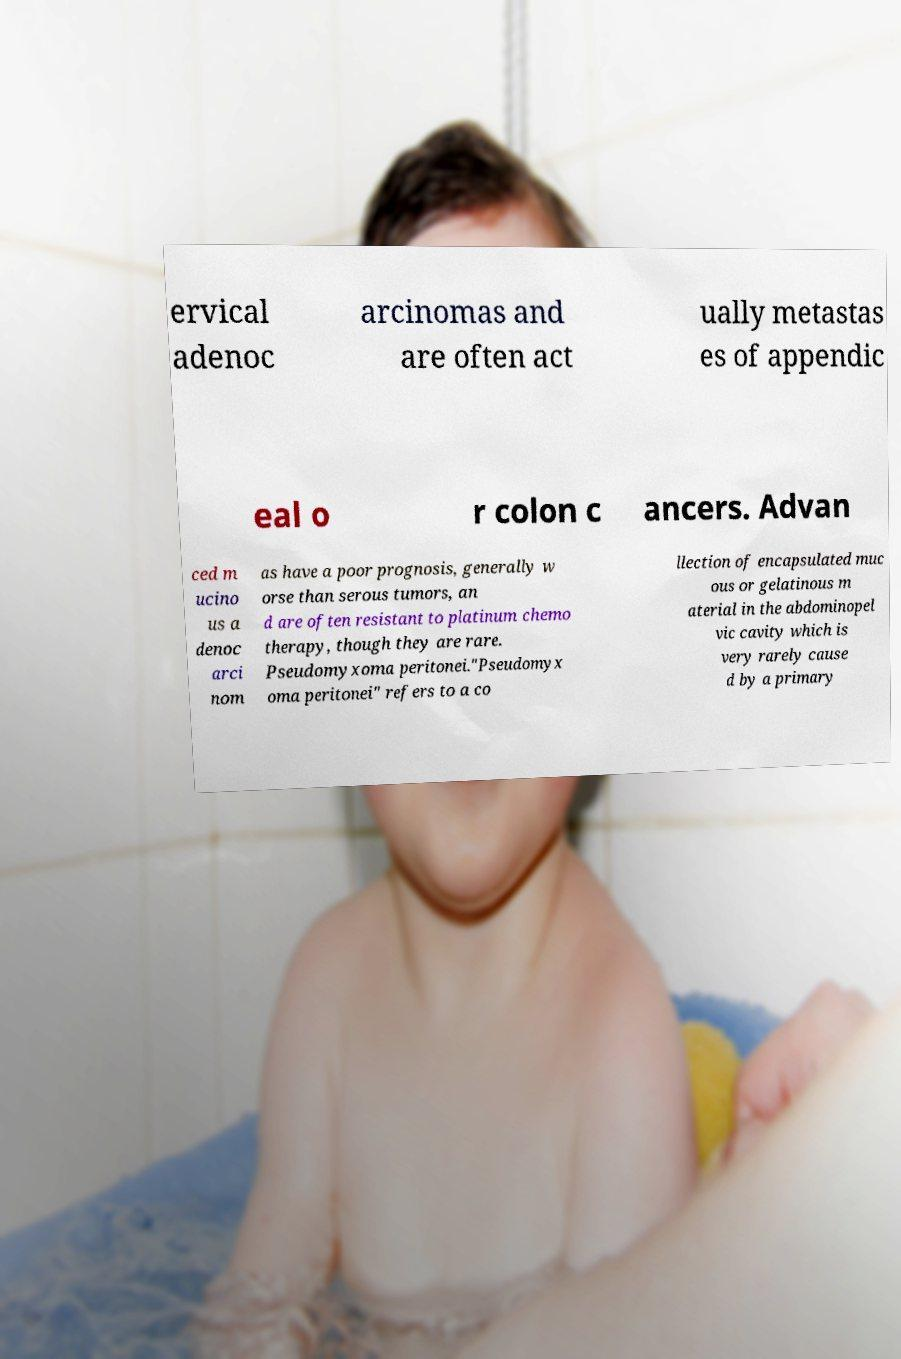For documentation purposes, I need the text within this image transcribed. Could you provide that? ervical adenoc arcinomas and are often act ually metastas es of appendic eal o r colon c ancers. Advan ced m ucino us a denoc arci nom as have a poor prognosis, generally w orse than serous tumors, an d are often resistant to platinum chemo therapy, though they are rare. Pseudomyxoma peritonei."Pseudomyx oma peritonei" refers to a co llection of encapsulated muc ous or gelatinous m aterial in the abdominopel vic cavity which is very rarely cause d by a primary 